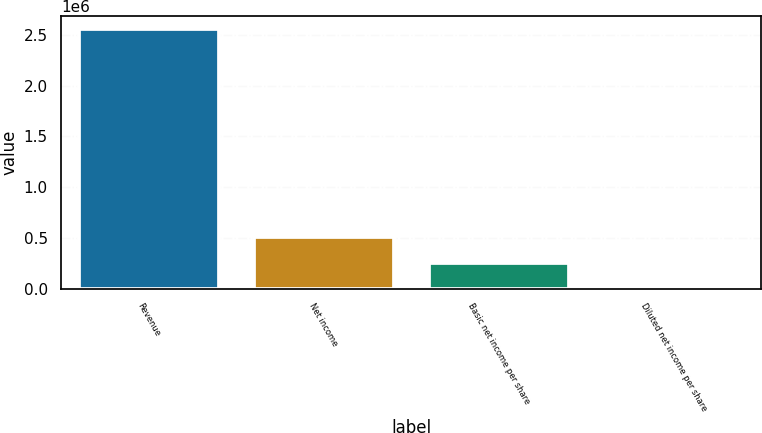<chart> <loc_0><loc_0><loc_500><loc_500><bar_chart><fcel>Revenue<fcel>Net income<fcel>Basic net income per share<fcel>Diluted net income per share<nl><fcel>2.55604e+06<fcel>511209<fcel>255605<fcel>0.2<nl></chart> 